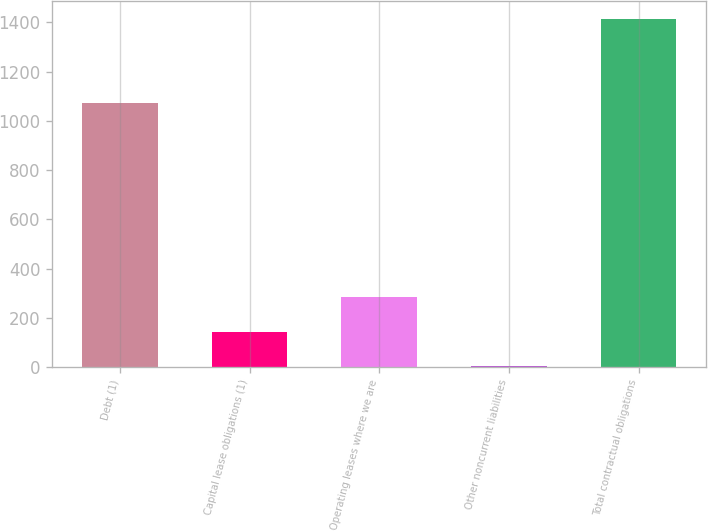Convert chart to OTSL. <chart><loc_0><loc_0><loc_500><loc_500><bar_chart><fcel>Debt (1)<fcel>Capital lease obligations (1)<fcel>Operating leases where we are<fcel>Other noncurrent liabilities<fcel>Total contractual obligations<nl><fcel>1074<fcel>144.1<fcel>285.2<fcel>3<fcel>1414<nl></chart> 